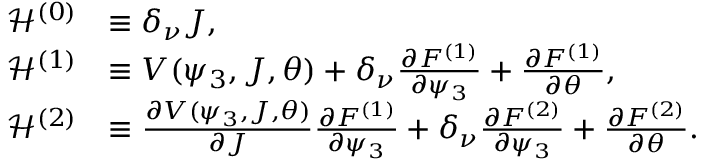<formula> <loc_0><loc_0><loc_500><loc_500>\begin{array} { r l } { \mathcal { H } ^ { \left ( 0 \right ) } } & { \equiv \delta _ { \nu } J , } \\ { \mathcal { H } ^ { ( 1 ) } } & { \equiv V ( \psi _ { 3 } , J , \theta ) + \delta _ { \nu } \frac { \partial F ^ { \left ( 1 \right ) } } { \partial \psi _ { 3 } } + \frac { \partial F ^ { \left ( 1 \right ) } } { \partial \theta } , } \\ { \mathcal { H } ^ { \left ( 2 \right ) } } & { \equiv \frac { \partial V ( \psi _ { 3 } , J , \theta ) } { \partial J } \frac { \partial F ^ { \left ( 1 \right ) } } { \partial \psi _ { 3 } } + \delta _ { \nu } \frac { \partial F ^ { \left ( 2 \right ) } } { \partial \psi _ { 3 } } + \frac { \partial F ^ { \left ( 2 \right ) } } { \partial \theta } . } \end{array}</formula> 